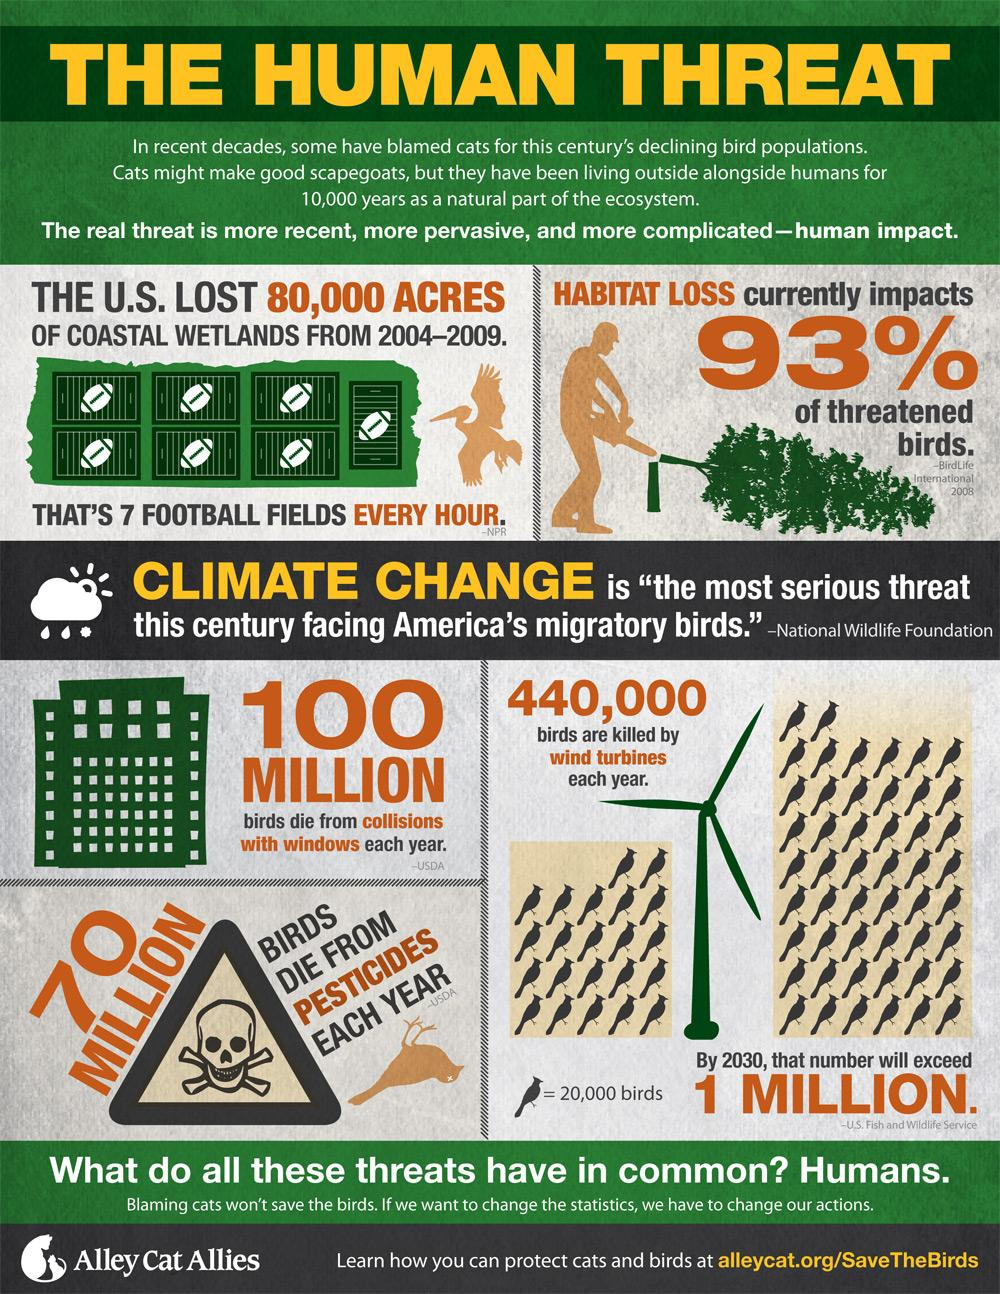List a handful of essential elements in this visual. According to current estimates, the number of bird deaths caused by turbines is expected to increase to 560,000 by 2030. 